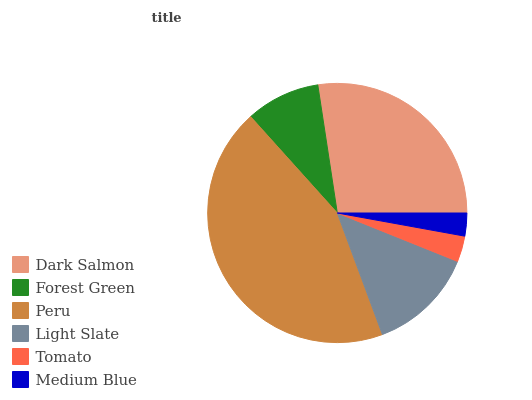Is Medium Blue the minimum?
Answer yes or no. Yes. Is Peru the maximum?
Answer yes or no. Yes. Is Forest Green the minimum?
Answer yes or no. No. Is Forest Green the maximum?
Answer yes or no. No. Is Dark Salmon greater than Forest Green?
Answer yes or no. Yes. Is Forest Green less than Dark Salmon?
Answer yes or no. Yes. Is Forest Green greater than Dark Salmon?
Answer yes or no. No. Is Dark Salmon less than Forest Green?
Answer yes or no. No. Is Light Slate the high median?
Answer yes or no. Yes. Is Forest Green the low median?
Answer yes or no. Yes. Is Peru the high median?
Answer yes or no. No. Is Light Slate the low median?
Answer yes or no. No. 